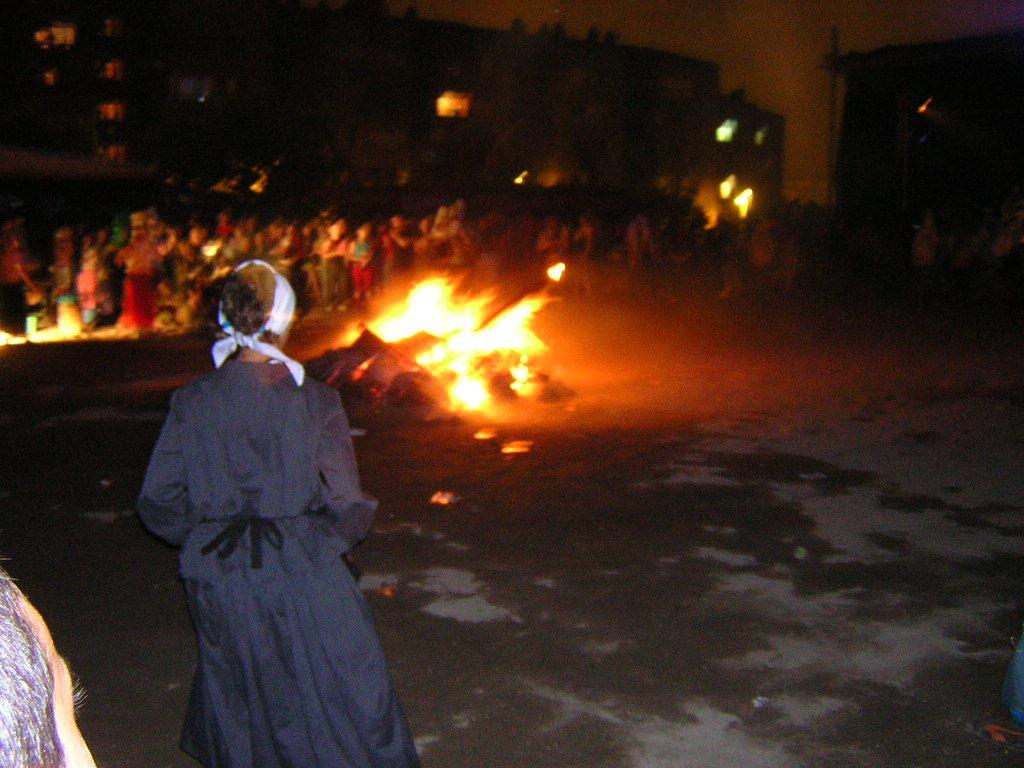What is the main subject of the image? There is a person standing in the image. What is happening in the background of the image? There appears to be a fire in the image. How many people are present in the image? There is a group of people standing in the image. What can be seen in the buildings in the image? There are buildings with lighting in the image. What is the porter doing with his hands in the image? There is no porter present in the image, and therefore no such activity can be observed. Can you tell me how many stomachs are visible in the image? There are no stomachs visible in the image. 